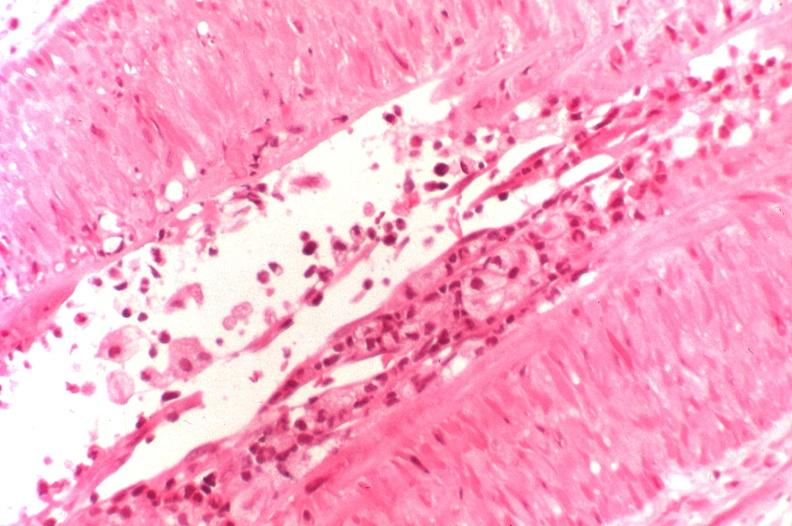does example show kidney transplant rejection?
Answer the question using a single word or phrase. No 